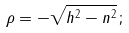<formula> <loc_0><loc_0><loc_500><loc_500>\rho = - { \sqrt { h ^ { 2 } - n ^ { 2 } } } \, ;</formula> 